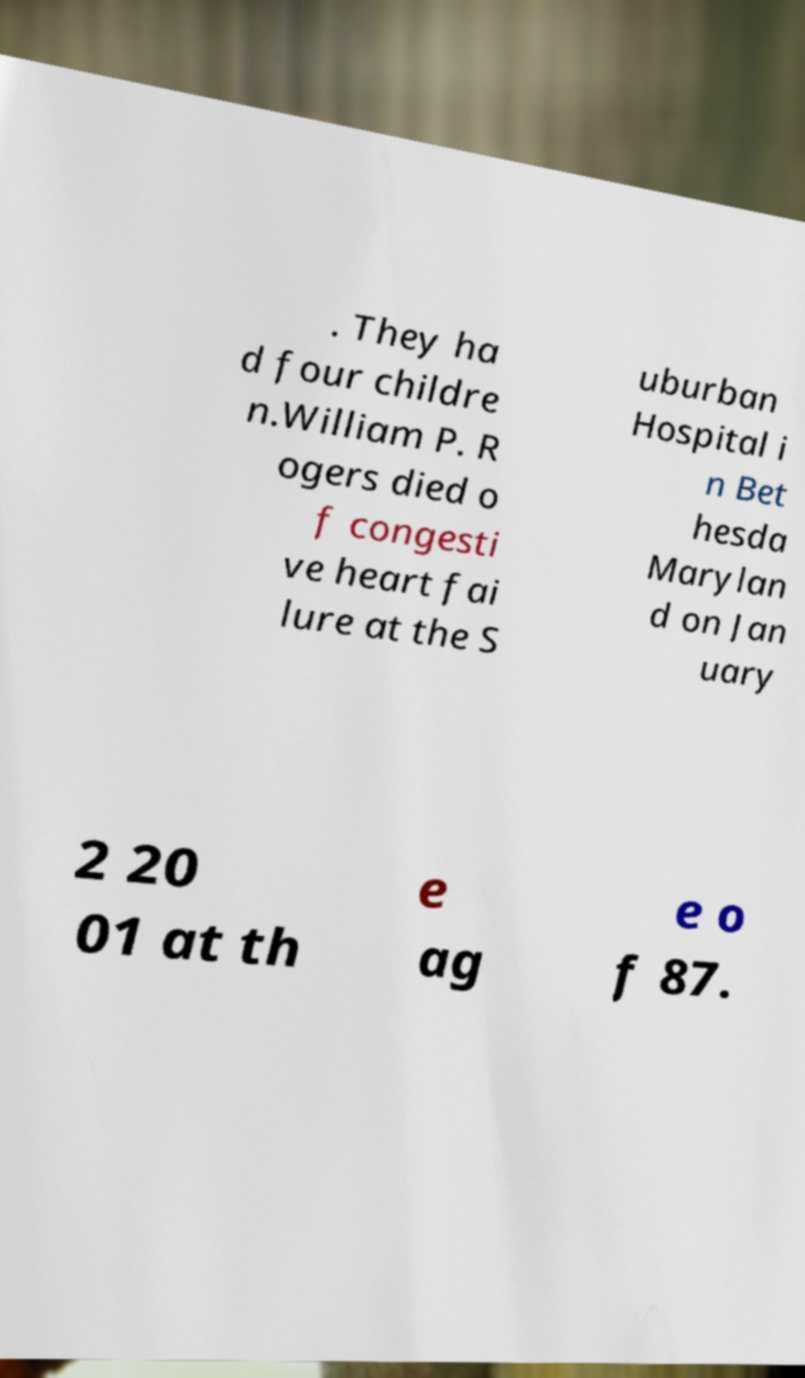Please identify and transcribe the text found in this image. . They ha d four childre n.William P. R ogers died o f congesti ve heart fai lure at the S uburban Hospital i n Bet hesda Marylan d on Jan uary 2 20 01 at th e ag e o f 87. 